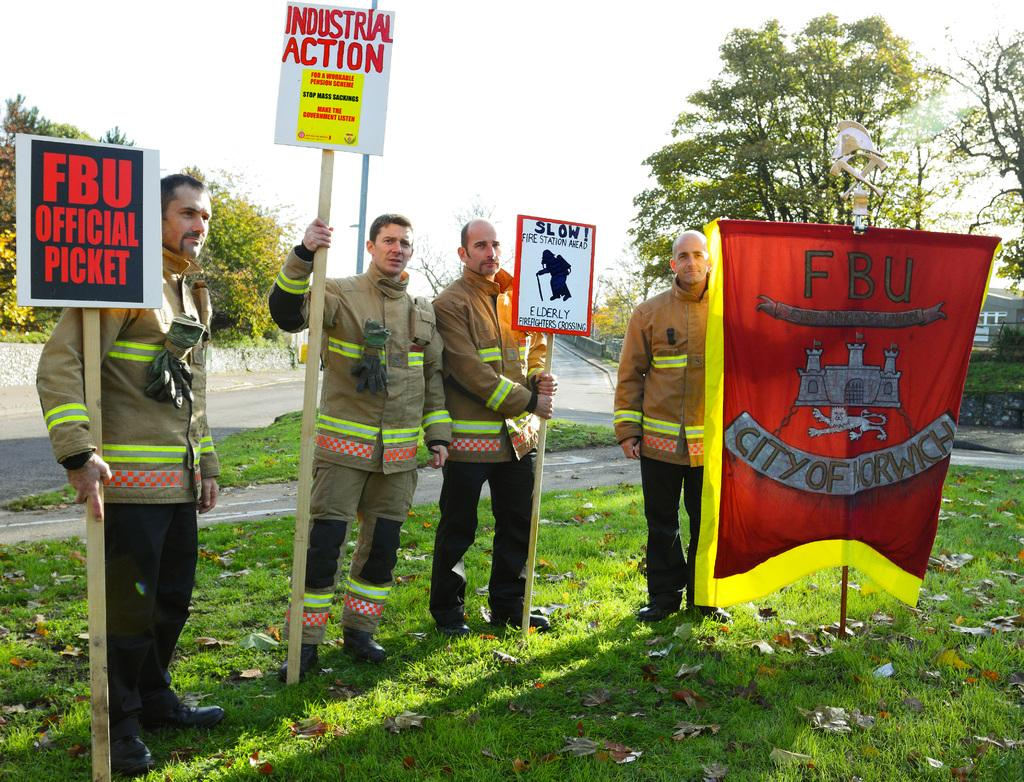What are the people in the image doing? The people in the image are standing on the grass. What are some of the people holding? Some people are holding placards. What can be seen in the background of the image? There are trees and a house in the background. What type of authority figure can be seen in the image? There is no authority figure present in the image. What is the grandfather doing in the image? There is no grandfather present in the image. 